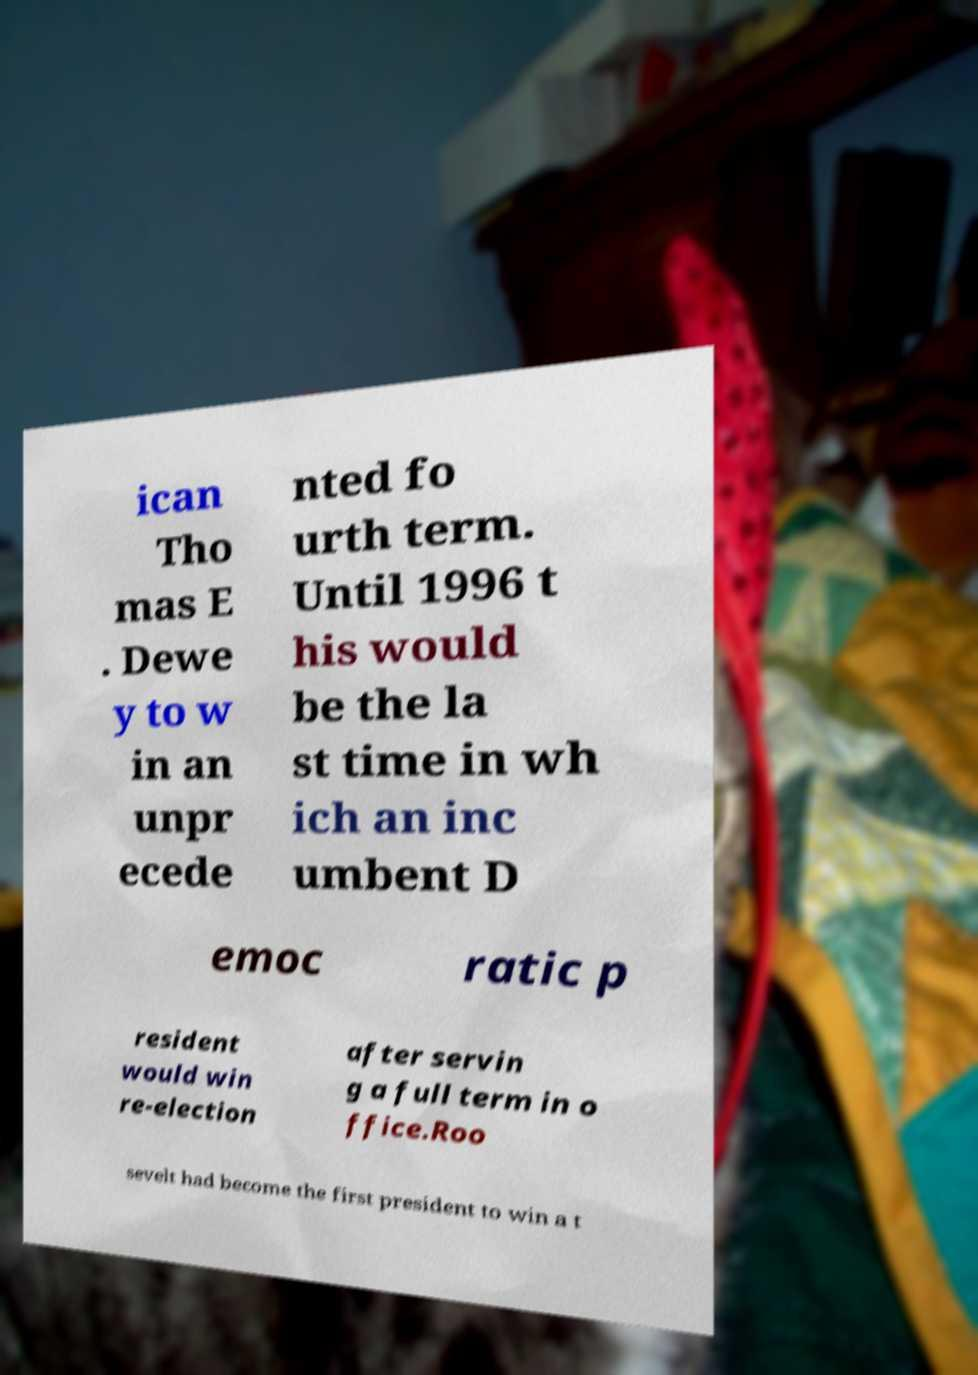Please read and relay the text visible in this image. What does it say? ican Tho mas E . Dewe y to w in an unpr ecede nted fo urth term. Until 1996 t his would be the la st time in wh ich an inc umbent D emoc ratic p resident would win re-election after servin g a full term in o ffice.Roo sevelt had become the first president to win a t 